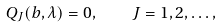Convert formula to latex. <formula><loc_0><loc_0><loc_500><loc_500>Q _ { J } ( b , \lambda ) = 0 , \quad J = 1 , 2 , \dots ,</formula> 